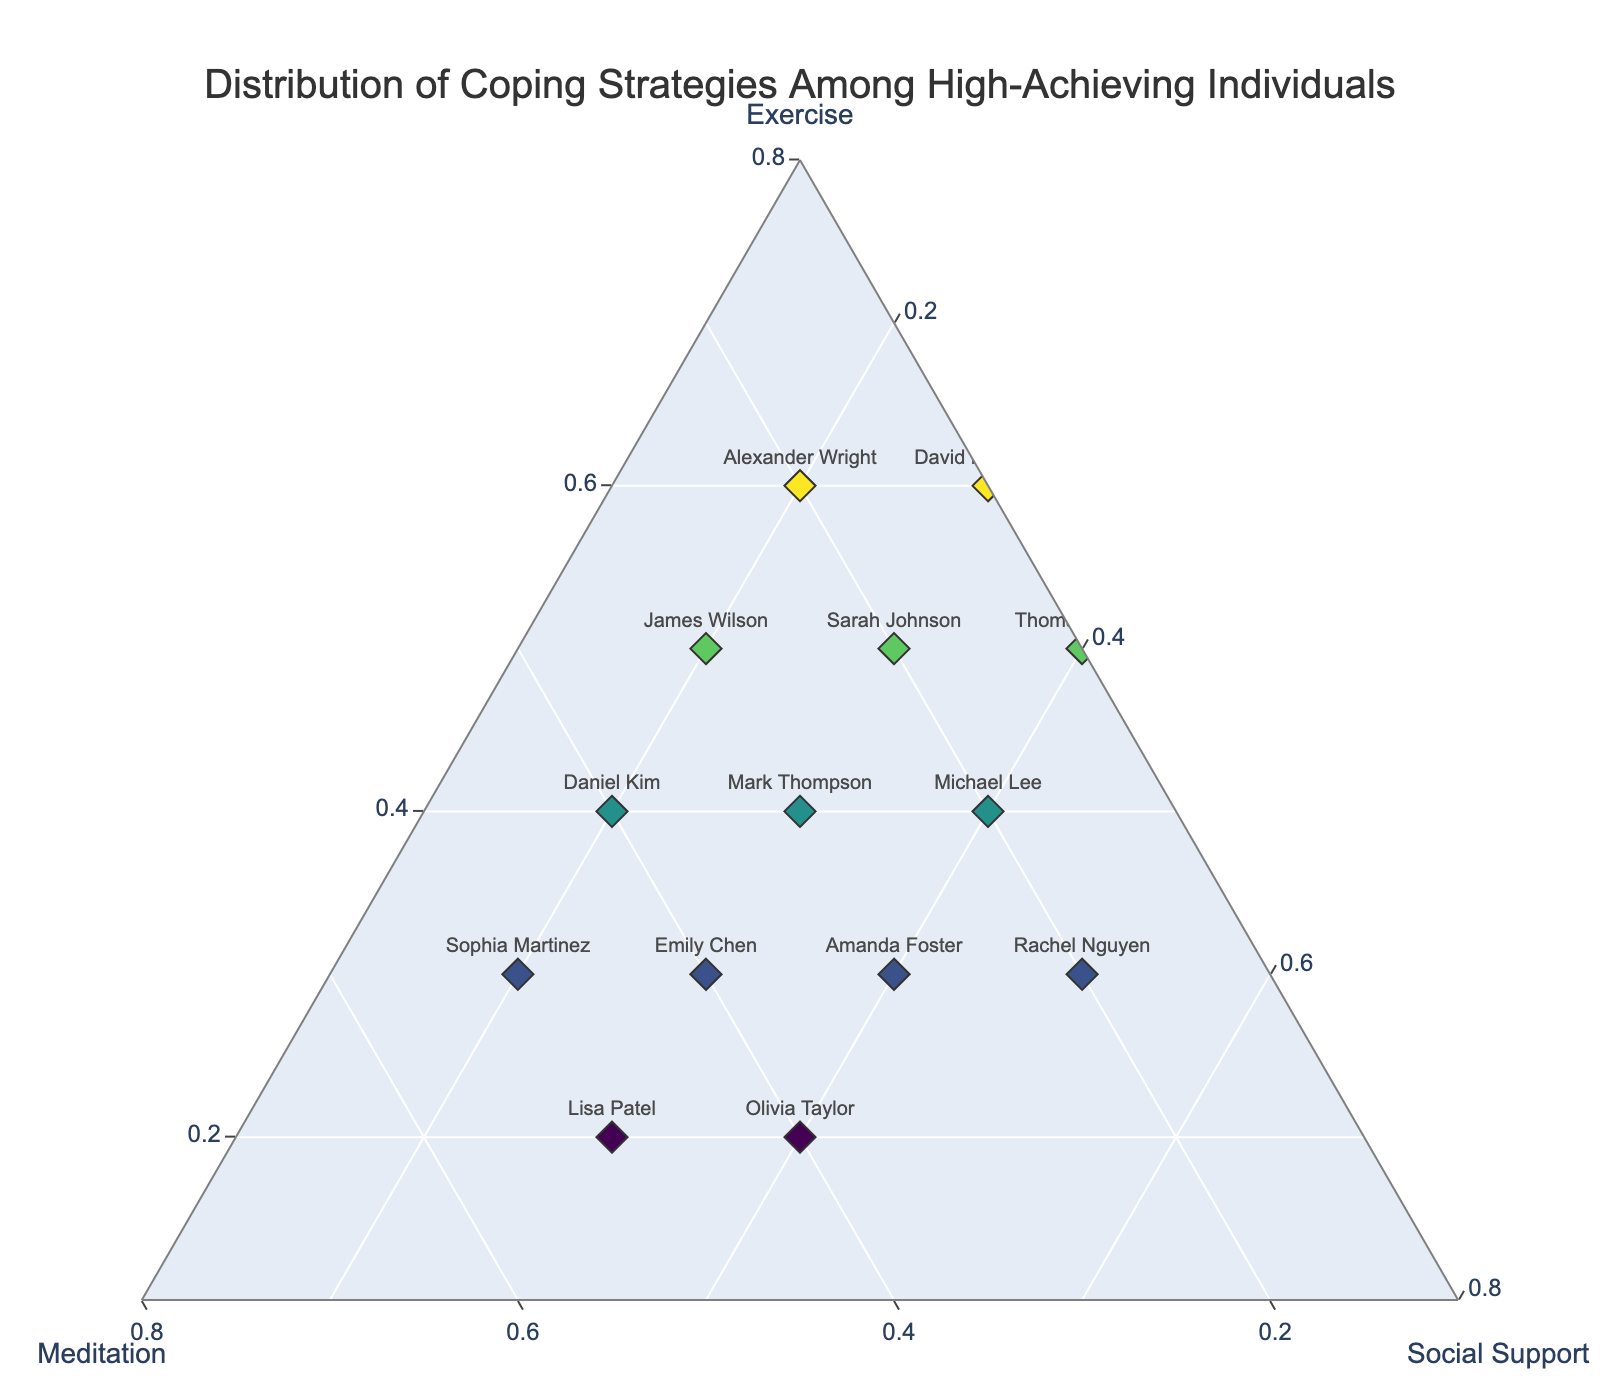How many data points are there in the plot? To determine the number of data points, count the number of names displayed in the plot. Each name represents one individual's data point.
Answer: 14 What coping strategy has the highest percentage for Thomas Brown? Look at Thomas Brown's position on the ternary plot and identify the largest component among Exercise, Meditation, and Social Support.
Answer: Exercise Which individual relies the most on Meditation? Find the data point closest to the Meditation axis with the highest Meditation value. Read the associated name label for that data point.
Answer: Lisa Patel Who has an equal distribution of Exercise and Meditation but a different Social Support value? Look for data points where the Exercise (a) and Meditation (b) percentages are the same but have a different Social Support (c) percentage and identify the corresponding individual.
Answer: Mark Thompson Compare David Rodriguez and Alexander Wright. Who has a higher dependency on Social Support? Identify the positions of David Rodriguez and Alexander Wright on the ternary plot and compare their Social Support values.
Answer: David Rodriguez Which individual has the lowest Exercise percentage? Look for the data point closest to the base of the Exercise axis and identify the associated individual.
Answer: Lisa Patel Are there more people who have Social Support as their highest strategy compared to Meditation? Count the number of data points where Social Support is the highest component and compare it with the count of those where Meditation is the highest.
Answer: No Calculate the average percentage of Exercise for all individuals. Add up the Exercise percentages for all individuals and divide by the total number of individuals (14). The values to sum are 0.5, 0.4, 0.3, 0.6, 0.2, 0.4, 0.3, 0.5, 0.2, 0.4, 0.3, 0.5, 0.3, 0.6. The calculation is (0.5 + 0.4 + 0.3 + 0.6 + 0.2 + 0.4 + 0.3 + 0.5 + 0.2 + 0.4 + 0.3 + 0.5 + 0.3 + 0.6) / 14.
Answer: 0.4 Identify the area with the densest clustering of points. Observe the plot to determine which region (e.g., nearest a vertex or along a particular axis) has the most data points closely located together.
Answer: Near Exercise Vertex Who has an even split between all three coping strategies? Look for the data point closest to the center of the ternary plot where Exercise, Meditation, and Social Support values are roughly equal.
Answer: No one 